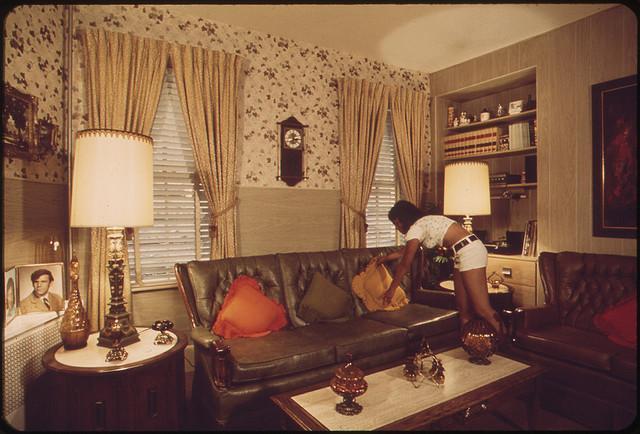How many couches are there?
Give a very brief answer. 2. How many banana stems without bananas are there?
Give a very brief answer. 0. 